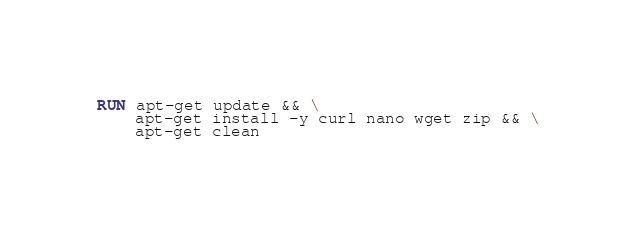Convert code to text. <code><loc_0><loc_0><loc_500><loc_500><_Dockerfile_>
RUN apt-get update && \
    apt-get install -y curl nano wget zip && \
    apt-get clean
</code> 